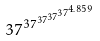<formula> <loc_0><loc_0><loc_500><loc_500>3 7 ^ { 3 7 ^ { 3 7 ^ { 3 7 ^ { 3 7 ^ { 4 . 8 5 9 } } } } }</formula> 